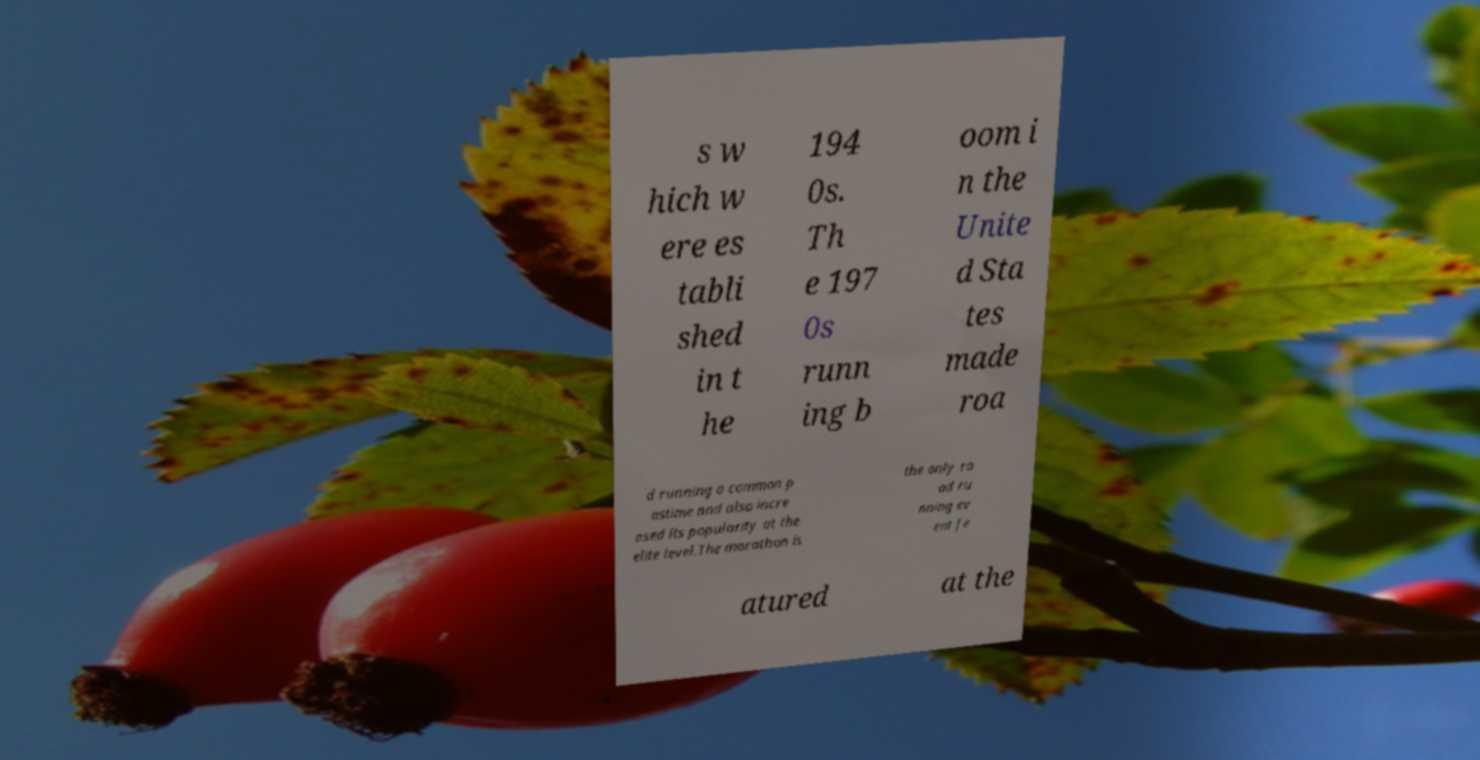Please read and relay the text visible in this image. What does it say? s w hich w ere es tabli shed in t he 194 0s. Th e 197 0s runn ing b oom i n the Unite d Sta tes made roa d running a common p astime and also incre ased its popularity at the elite level.The marathon is the only ro ad ru nning ev ent fe atured at the 